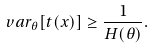Convert formula to latex. <formula><loc_0><loc_0><loc_500><loc_500>v a r _ { \theta } [ t ( x ) ] \geq \frac { 1 } { H ( \theta ) } .</formula> 